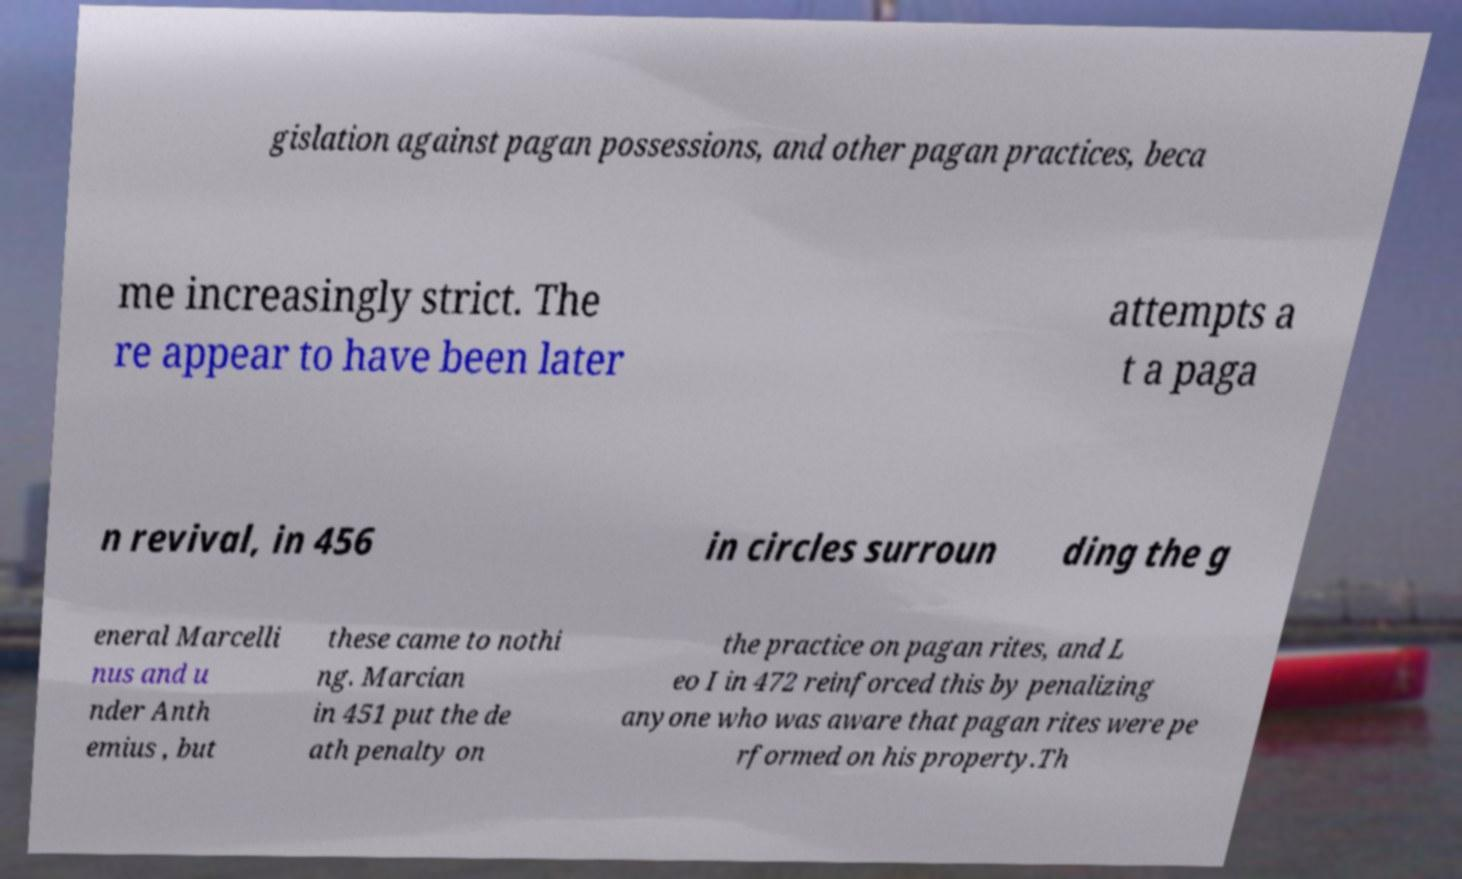Can you accurately transcribe the text from the provided image for me? gislation against pagan possessions, and other pagan practices, beca me increasingly strict. The re appear to have been later attempts a t a paga n revival, in 456 in circles surroun ding the g eneral Marcelli nus and u nder Anth emius , but these came to nothi ng. Marcian in 451 put the de ath penalty on the practice on pagan rites, and L eo I in 472 reinforced this by penalizing anyone who was aware that pagan rites were pe rformed on his property.Th 